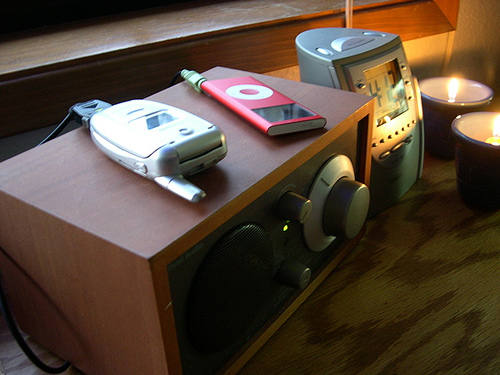<image>
Can you confirm if the ipod is on the table? No. The ipod is not positioned on the table. They may be near each other, but the ipod is not supported by or resting on top of the table. Where is the mobile phone in relation to the table? Is it above the table? Yes. The mobile phone is positioned above the table in the vertical space, higher up in the scene. 